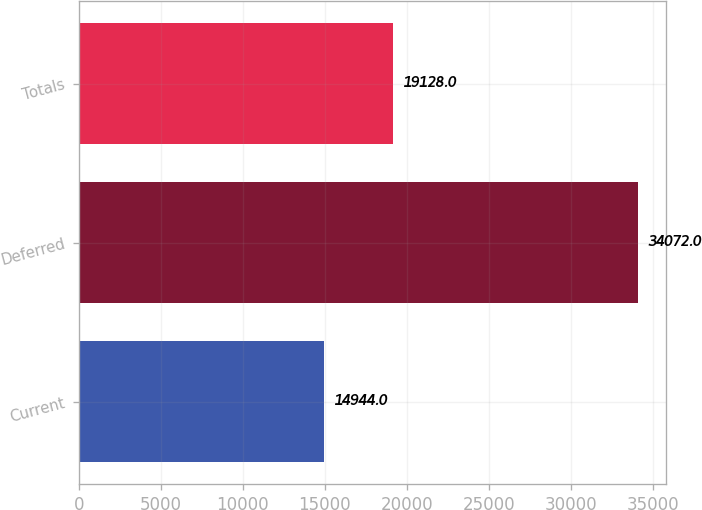Convert chart. <chart><loc_0><loc_0><loc_500><loc_500><bar_chart><fcel>Current<fcel>Deferred<fcel>Totals<nl><fcel>14944<fcel>34072<fcel>19128<nl></chart> 